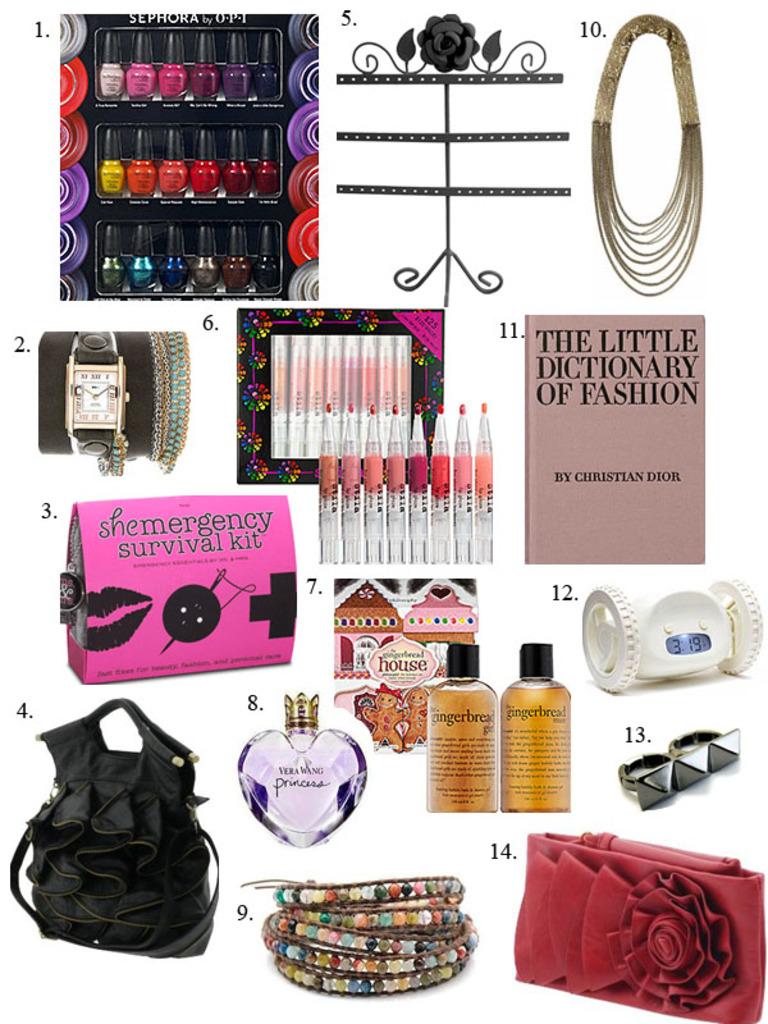What is the title of the book?
Your response must be concise. The little dictionary of fashion. What kind of survival kit is pictured?
Your answer should be compact. Shemergency. 